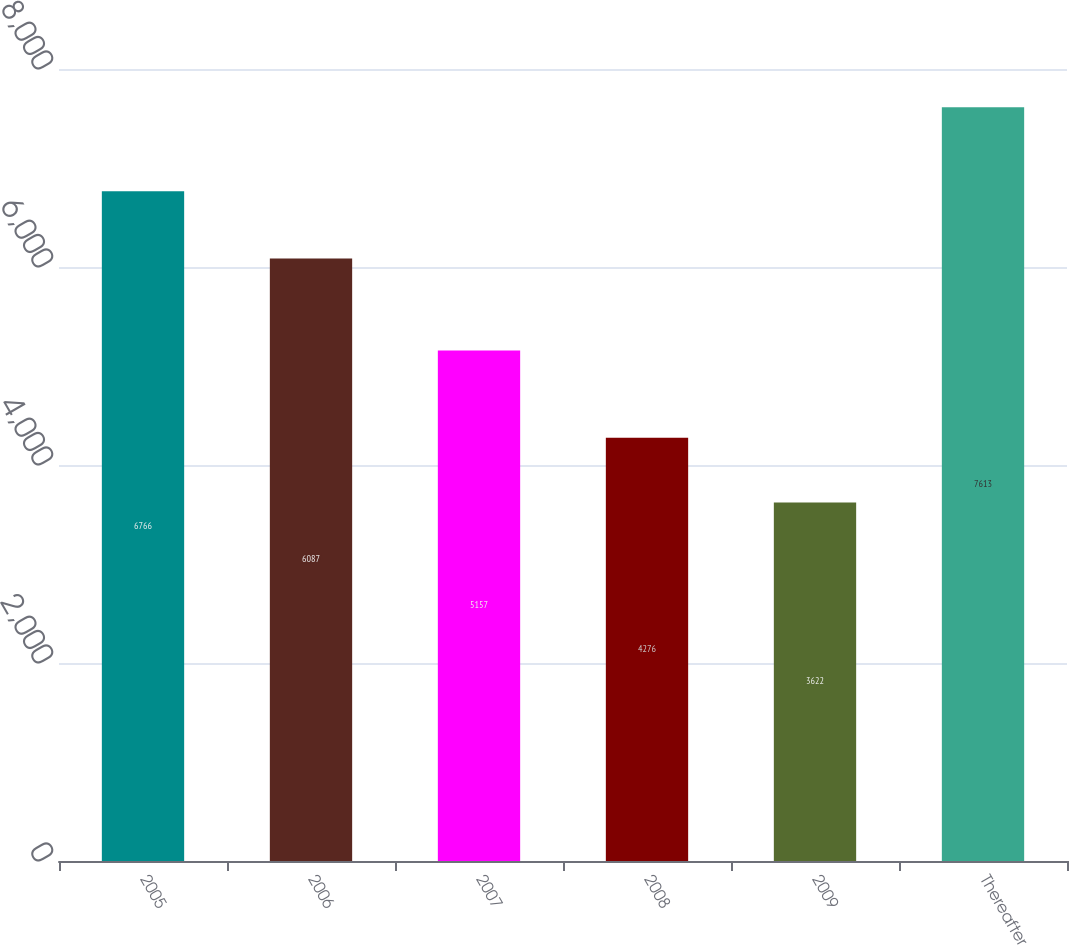<chart> <loc_0><loc_0><loc_500><loc_500><bar_chart><fcel>2005<fcel>2006<fcel>2007<fcel>2008<fcel>2009<fcel>Thereafter<nl><fcel>6766<fcel>6087<fcel>5157<fcel>4276<fcel>3622<fcel>7613<nl></chart> 